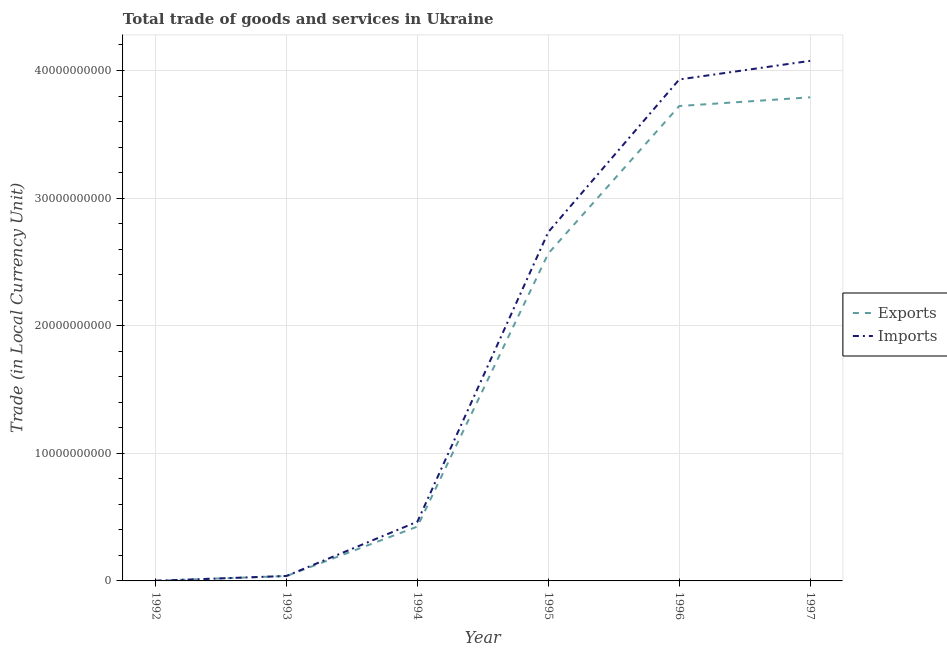Does the line corresponding to export of goods and services intersect with the line corresponding to imports of goods and services?
Offer a terse response. Yes. Is the number of lines equal to the number of legend labels?
Keep it short and to the point. Yes. What is the imports of goods and services in 1997?
Your answer should be very brief. 4.08e+1. Across all years, what is the maximum export of goods and services?
Give a very brief answer. 3.79e+1. Across all years, what is the minimum imports of goods and services?
Keep it short and to the point. 1.11e+07. In which year was the export of goods and services minimum?
Your answer should be compact. 1992. What is the total imports of goods and services in the graph?
Your answer should be very brief. 1.12e+11. What is the difference between the imports of goods and services in 1992 and that in 1994?
Your response must be concise. -4.63e+09. What is the difference between the export of goods and services in 1994 and the imports of goods and services in 1997?
Your answer should be very brief. -3.65e+1. What is the average export of goods and services per year?
Offer a very short reply. 1.76e+1. In the year 1993, what is the difference between the export of goods and services and imports of goods and services?
Your answer should be compact. -4.64e+06. In how many years, is the export of goods and services greater than 22000000000 LCU?
Provide a short and direct response. 3. What is the ratio of the imports of goods and services in 1995 to that in 1997?
Ensure brevity in your answer.  0.67. What is the difference between the highest and the second highest export of goods and services?
Provide a short and direct response. 6.83e+08. What is the difference between the highest and the lowest export of goods and services?
Your answer should be compact. 3.79e+1. In how many years, is the export of goods and services greater than the average export of goods and services taken over all years?
Offer a very short reply. 3. Does the imports of goods and services monotonically increase over the years?
Make the answer very short. Yes. How many lines are there?
Your answer should be very brief. 2. How many years are there in the graph?
Offer a very short reply. 6. Where does the legend appear in the graph?
Your answer should be compact. Center right. What is the title of the graph?
Your answer should be compact. Total trade of goods and services in Ukraine. Does "Forest" appear as one of the legend labels in the graph?
Provide a short and direct response. No. What is the label or title of the Y-axis?
Offer a very short reply. Trade (in Local Currency Unit). What is the Trade (in Local Currency Unit) in Exports in 1992?
Give a very brief answer. 1.21e+07. What is the Trade (in Local Currency Unit) of Imports in 1992?
Your answer should be very brief. 1.11e+07. What is the Trade (in Local Currency Unit) in Exports in 1993?
Make the answer very short. 3.84e+08. What is the Trade (in Local Currency Unit) in Imports in 1993?
Provide a succinct answer. 3.88e+08. What is the Trade (in Local Currency Unit) of Exports in 1994?
Your response must be concise. 4.26e+09. What is the Trade (in Local Currency Unit) of Imports in 1994?
Offer a terse response. 4.64e+09. What is the Trade (in Local Currency Unit) in Exports in 1995?
Give a very brief answer. 2.57e+1. What is the Trade (in Local Currency Unit) in Imports in 1995?
Your answer should be compact. 2.73e+1. What is the Trade (in Local Currency Unit) of Exports in 1996?
Your answer should be compact. 3.72e+1. What is the Trade (in Local Currency Unit) of Imports in 1996?
Keep it short and to the point. 3.93e+1. What is the Trade (in Local Currency Unit) in Exports in 1997?
Your answer should be very brief. 3.79e+1. What is the Trade (in Local Currency Unit) of Imports in 1997?
Offer a terse response. 4.08e+1. Across all years, what is the maximum Trade (in Local Currency Unit) of Exports?
Give a very brief answer. 3.79e+1. Across all years, what is the maximum Trade (in Local Currency Unit) of Imports?
Provide a short and direct response. 4.08e+1. Across all years, what is the minimum Trade (in Local Currency Unit) of Exports?
Your answer should be compact. 1.21e+07. Across all years, what is the minimum Trade (in Local Currency Unit) in Imports?
Ensure brevity in your answer.  1.11e+07. What is the total Trade (in Local Currency Unit) in Exports in the graph?
Your response must be concise. 1.05e+11. What is the total Trade (in Local Currency Unit) in Imports in the graph?
Keep it short and to the point. 1.12e+11. What is the difference between the Trade (in Local Currency Unit) of Exports in 1992 and that in 1993?
Keep it short and to the point. -3.72e+08. What is the difference between the Trade (in Local Currency Unit) in Imports in 1992 and that in 1993?
Make the answer very short. -3.77e+08. What is the difference between the Trade (in Local Currency Unit) of Exports in 1992 and that in 1994?
Give a very brief answer. -4.25e+09. What is the difference between the Trade (in Local Currency Unit) in Imports in 1992 and that in 1994?
Ensure brevity in your answer.  -4.63e+09. What is the difference between the Trade (in Local Currency Unit) in Exports in 1992 and that in 1995?
Keep it short and to the point. -2.57e+1. What is the difference between the Trade (in Local Currency Unit) of Imports in 1992 and that in 1995?
Provide a succinct answer. -2.73e+1. What is the difference between the Trade (in Local Currency Unit) of Exports in 1992 and that in 1996?
Keep it short and to the point. -3.72e+1. What is the difference between the Trade (in Local Currency Unit) of Imports in 1992 and that in 1996?
Ensure brevity in your answer.  -3.93e+1. What is the difference between the Trade (in Local Currency Unit) of Exports in 1992 and that in 1997?
Your answer should be very brief. -3.79e+1. What is the difference between the Trade (in Local Currency Unit) in Imports in 1992 and that in 1997?
Your answer should be compact. -4.07e+1. What is the difference between the Trade (in Local Currency Unit) of Exports in 1993 and that in 1994?
Offer a very short reply. -3.88e+09. What is the difference between the Trade (in Local Currency Unit) in Imports in 1993 and that in 1994?
Provide a short and direct response. -4.25e+09. What is the difference between the Trade (in Local Currency Unit) of Exports in 1993 and that in 1995?
Give a very brief answer. -2.53e+1. What is the difference between the Trade (in Local Currency Unit) in Imports in 1993 and that in 1995?
Your answer should be compact. -2.70e+1. What is the difference between the Trade (in Local Currency Unit) in Exports in 1993 and that in 1996?
Give a very brief answer. -3.68e+1. What is the difference between the Trade (in Local Currency Unit) in Imports in 1993 and that in 1996?
Provide a succinct answer. -3.89e+1. What is the difference between the Trade (in Local Currency Unit) of Exports in 1993 and that in 1997?
Give a very brief answer. -3.75e+1. What is the difference between the Trade (in Local Currency Unit) of Imports in 1993 and that in 1997?
Provide a succinct answer. -4.04e+1. What is the difference between the Trade (in Local Currency Unit) in Exports in 1994 and that in 1995?
Ensure brevity in your answer.  -2.14e+1. What is the difference between the Trade (in Local Currency Unit) of Imports in 1994 and that in 1995?
Your answer should be very brief. -2.27e+1. What is the difference between the Trade (in Local Currency Unit) in Exports in 1994 and that in 1996?
Your answer should be very brief. -3.30e+1. What is the difference between the Trade (in Local Currency Unit) in Imports in 1994 and that in 1996?
Your answer should be compact. -3.47e+1. What is the difference between the Trade (in Local Currency Unit) in Exports in 1994 and that in 1997?
Keep it short and to the point. -3.36e+1. What is the difference between the Trade (in Local Currency Unit) of Imports in 1994 and that in 1997?
Make the answer very short. -3.61e+1. What is the difference between the Trade (in Local Currency Unit) of Exports in 1995 and that in 1996?
Your answer should be very brief. -1.16e+1. What is the difference between the Trade (in Local Currency Unit) of Imports in 1995 and that in 1996?
Make the answer very short. -1.20e+1. What is the difference between the Trade (in Local Currency Unit) in Exports in 1995 and that in 1997?
Your response must be concise. -1.22e+1. What is the difference between the Trade (in Local Currency Unit) in Imports in 1995 and that in 1997?
Your answer should be compact. -1.34e+1. What is the difference between the Trade (in Local Currency Unit) in Exports in 1996 and that in 1997?
Provide a short and direct response. -6.83e+08. What is the difference between the Trade (in Local Currency Unit) of Imports in 1996 and that in 1997?
Your answer should be very brief. -1.46e+09. What is the difference between the Trade (in Local Currency Unit) in Exports in 1992 and the Trade (in Local Currency Unit) in Imports in 1993?
Give a very brief answer. -3.76e+08. What is the difference between the Trade (in Local Currency Unit) in Exports in 1992 and the Trade (in Local Currency Unit) in Imports in 1994?
Keep it short and to the point. -4.63e+09. What is the difference between the Trade (in Local Currency Unit) in Exports in 1992 and the Trade (in Local Currency Unit) in Imports in 1995?
Make the answer very short. -2.73e+1. What is the difference between the Trade (in Local Currency Unit) in Exports in 1992 and the Trade (in Local Currency Unit) in Imports in 1996?
Keep it short and to the point. -3.93e+1. What is the difference between the Trade (in Local Currency Unit) in Exports in 1992 and the Trade (in Local Currency Unit) in Imports in 1997?
Offer a very short reply. -4.07e+1. What is the difference between the Trade (in Local Currency Unit) of Exports in 1993 and the Trade (in Local Currency Unit) of Imports in 1994?
Provide a short and direct response. -4.26e+09. What is the difference between the Trade (in Local Currency Unit) of Exports in 1993 and the Trade (in Local Currency Unit) of Imports in 1995?
Provide a succinct answer. -2.70e+1. What is the difference between the Trade (in Local Currency Unit) of Exports in 1993 and the Trade (in Local Currency Unit) of Imports in 1996?
Offer a very short reply. -3.89e+1. What is the difference between the Trade (in Local Currency Unit) of Exports in 1993 and the Trade (in Local Currency Unit) of Imports in 1997?
Offer a terse response. -4.04e+1. What is the difference between the Trade (in Local Currency Unit) of Exports in 1994 and the Trade (in Local Currency Unit) of Imports in 1995?
Keep it short and to the point. -2.31e+1. What is the difference between the Trade (in Local Currency Unit) of Exports in 1994 and the Trade (in Local Currency Unit) of Imports in 1996?
Provide a succinct answer. -3.50e+1. What is the difference between the Trade (in Local Currency Unit) of Exports in 1994 and the Trade (in Local Currency Unit) of Imports in 1997?
Offer a very short reply. -3.65e+1. What is the difference between the Trade (in Local Currency Unit) in Exports in 1995 and the Trade (in Local Currency Unit) in Imports in 1996?
Make the answer very short. -1.36e+1. What is the difference between the Trade (in Local Currency Unit) of Exports in 1995 and the Trade (in Local Currency Unit) of Imports in 1997?
Ensure brevity in your answer.  -1.51e+1. What is the difference between the Trade (in Local Currency Unit) of Exports in 1996 and the Trade (in Local Currency Unit) of Imports in 1997?
Offer a very short reply. -3.54e+09. What is the average Trade (in Local Currency Unit) in Exports per year?
Your response must be concise. 1.76e+1. What is the average Trade (in Local Currency Unit) in Imports per year?
Ensure brevity in your answer.  1.87e+1. In the year 1992, what is the difference between the Trade (in Local Currency Unit) of Exports and Trade (in Local Currency Unit) of Imports?
Provide a succinct answer. 1.00e+06. In the year 1993, what is the difference between the Trade (in Local Currency Unit) of Exports and Trade (in Local Currency Unit) of Imports?
Make the answer very short. -4.64e+06. In the year 1994, what is the difference between the Trade (in Local Currency Unit) of Exports and Trade (in Local Currency Unit) of Imports?
Your answer should be compact. -3.81e+08. In the year 1995, what is the difference between the Trade (in Local Currency Unit) in Exports and Trade (in Local Currency Unit) in Imports?
Keep it short and to the point. -1.68e+09. In the year 1996, what is the difference between the Trade (in Local Currency Unit) in Exports and Trade (in Local Currency Unit) in Imports?
Your answer should be very brief. -2.08e+09. In the year 1997, what is the difference between the Trade (in Local Currency Unit) of Exports and Trade (in Local Currency Unit) of Imports?
Keep it short and to the point. -2.86e+09. What is the ratio of the Trade (in Local Currency Unit) in Exports in 1992 to that in 1993?
Make the answer very short. 0.03. What is the ratio of the Trade (in Local Currency Unit) of Imports in 1992 to that in 1993?
Make the answer very short. 0.03. What is the ratio of the Trade (in Local Currency Unit) in Exports in 1992 to that in 1994?
Provide a succinct answer. 0. What is the ratio of the Trade (in Local Currency Unit) in Imports in 1992 to that in 1994?
Offer a terse response. 0. What is the ratio of the Trade (in Local Currency Unit) of Exports in 1992 to that in 1995?
Provide a short and direct response. 0. What is the ratio of the Trade (in Local Currency Unit) in Exports in 1992 to that in 1996?
Offer a terse response. 0. What is the ratio of the Trade (in Local Currency Unit) in Exports in 1993 to that in 1994?
Give a very brief answer. 0.09. What is the ratio of the Trade (in Local Currency Unit) of Imports in 1993 to that in 1994?
Provide a succinct answer. 0.08. What is the ratio of the Trade (in Local Currency Unit) of Exports in 1993 to that in 1995?
Make the answer very short. 0.01. What is the ratio of the Trade (in Local Currency Unit) of Imports in 1993 to that in 1995?
Ensure brevity in your answer.  0.01. What is the ratio of the Trade (in Local Currency Unit) in Exports in 1993 to that in 1996?
Ensure brevity in your answer.  0.01. What is the ratio of the Trade (in Local Currency Unit) in Imports in 1993 to that in 1996?
Provide a succinct answer. 0.01. What is the ratio of the Trade (in Local Currency Unit) in Exports in 1993 to that in 1997?
Your answer should be compact. 0.01. What is the ratio of the Trade (in Local Currency Unit) in Imports in 1993 to that in 1997?
Make the answer very short. 0.01. What is the ratio of the Trade (in Local Currency Unit) in Exports in 1994 to that in 1995?
Provide a short and direct response. 0.17. What is the ratio of the Trade (in Local Currency Unit) in Imports in 1994 to that in 1995?
Give a very brief answer. 0.17. What is the ratio of the Trade (in Local Currency Unit) of Exports in 1994 to that in 1996?
Offer a very short reply. 0.11. What is the ratio of the Trade (in Local Currency Unit) in Imports in 1994 to that in 1996?
Make the answer very short. 0.12. What is the ratio of the Trade (in Local Currency Unit) of Exports in 1994 to that in 1997?
Provide a succinct answer. 0.11. What is the ratio of the Trade (in Local Currency Unit) of Imports in 1994 to that in 1997?
Offer a very short reply. 0.11. What is the ratio of the Trade (in Local Currency Unit) in Exports in 1995 to that in 1996?
Your answer should be compact. 0.69. What is the ratio of the Trade (in Local Currency Unit) of Imports in 1995 to that in 1996?
Offer a terse response. 0.7. What is the ratio of the Trade (in Local Currency Unit) of Exports in 1995 to that in 1997?
Offer a terse response. 0.68. What is the ratio of the Trade (in Local Currency Unit) in Imports in 1995 to that in 1997?
Make the answer very short. 0.67. What is the ratio of the Trade (in Local Currency Unit) of Imports in 1996 to that in 1997?
Provide a short and direct response. 0.96. What is the difference between the highest and the second highest Trade (in Local Currency Unit) of Exports?
Provide a short and direct response. 6.83e+08. What is the difference between the highest and the second highest Trade (in Local Currency Unit) of Imports?
Ensure brevity in your answer.  1.46e+09. What is the difference between the highest and the lowest Trade (in Local Currency Unit) in Exports?
Ensure brevity in your answer.  3.79e+1. What is the difference between the highest and the lowest Trade (in Local Currency Unit) in Imports?
Your response must be concise. 4.07e+1. 